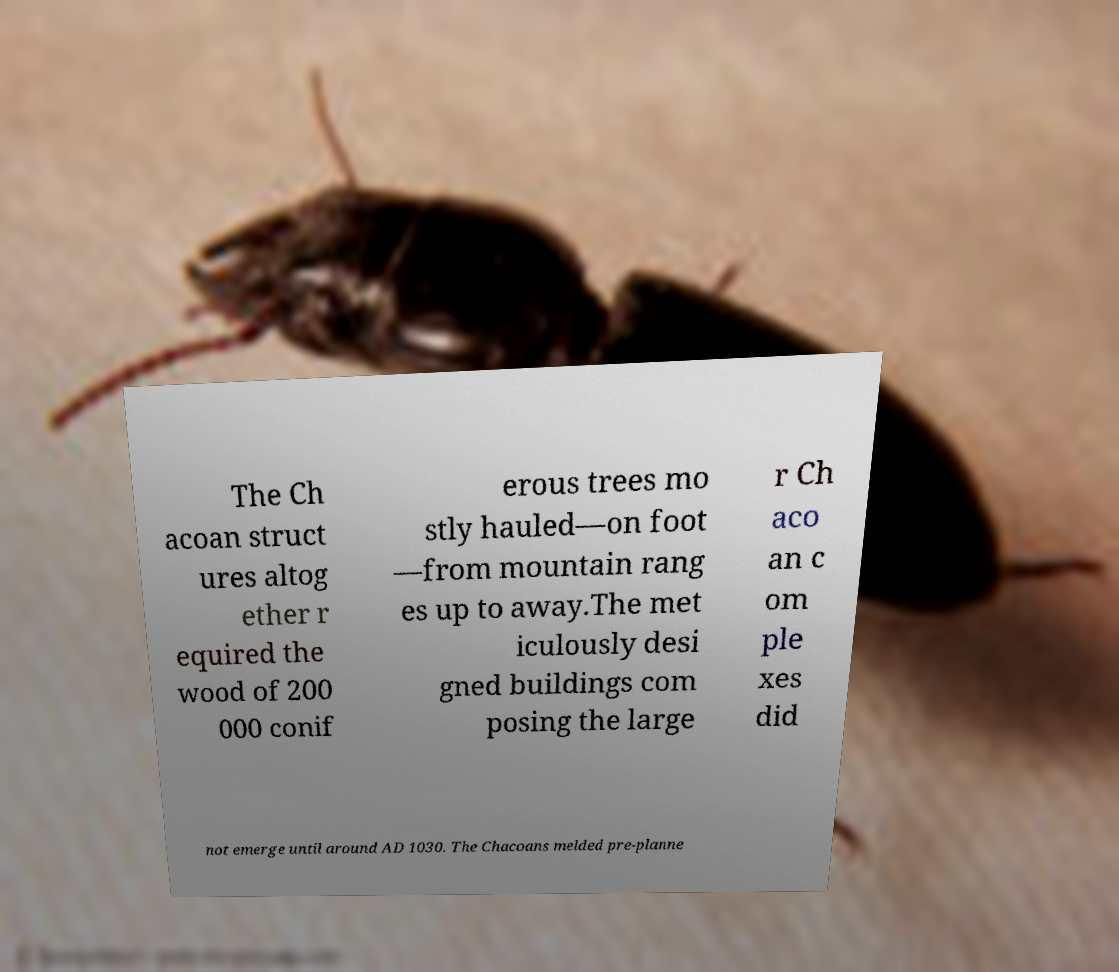What messages or text are displayed in this image? I need them in a readable, typed format. The Ch acoan struct ures altog ether r equired the wood of 200 000 conif erous trees mo stly hauled—on foot —from mountain rang es up to away.The met iculously desi gned buildings com posing the large r Ch aco an c om ple xes did not emerge until around AD 1030. The Chacoans melded pre-planne 